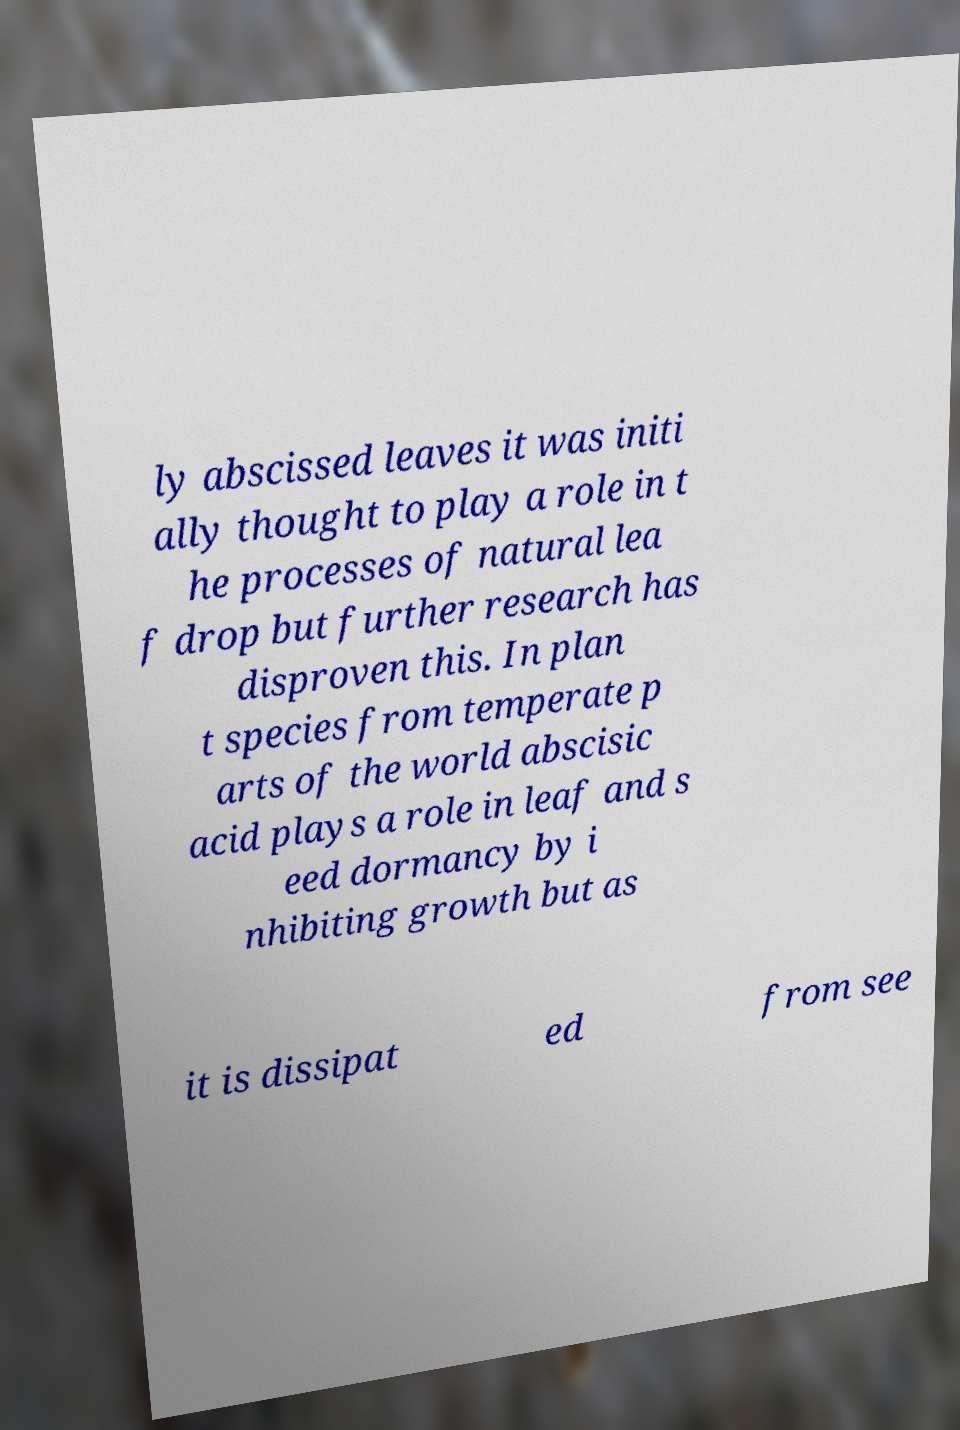For documentation purposes, I need the text within this image transcribed. Could you provide that? ly abscissed leaves it was initi ally thought to play a role in t he processes of natural lea f drop but further research has disproven this. In plan t species from temperate p arts of the world abscisic acid plays a role in leaf and s eed dormancy by i nhibiting growth but as it is dissipat ed from see 